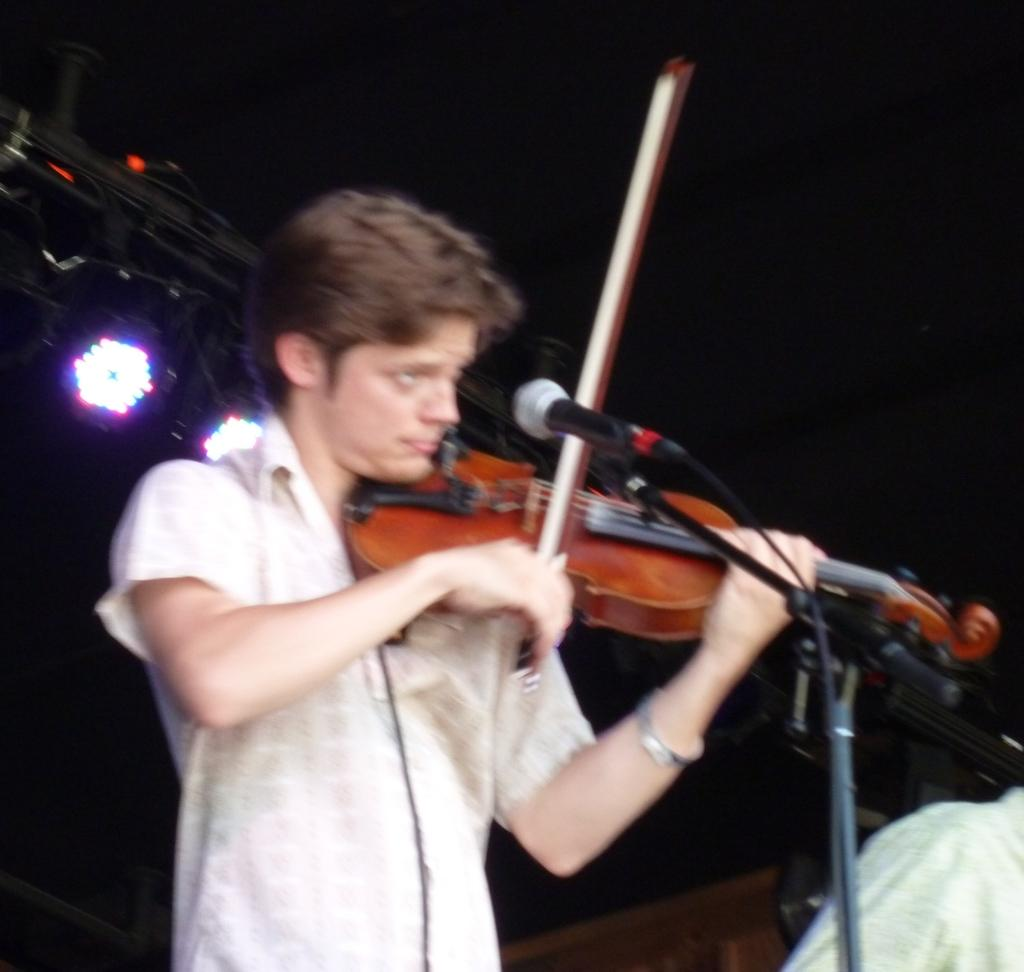Who is the main subject in the image? There is a man in the image. What is the man holding in the image? The man is holding a guitar. What object is in front of the man? There is a microphone in front of the man. What type of cheese is the man eating in the image? There is no cheese present in the image; the man is holding a guitar and standing near a microphone. 